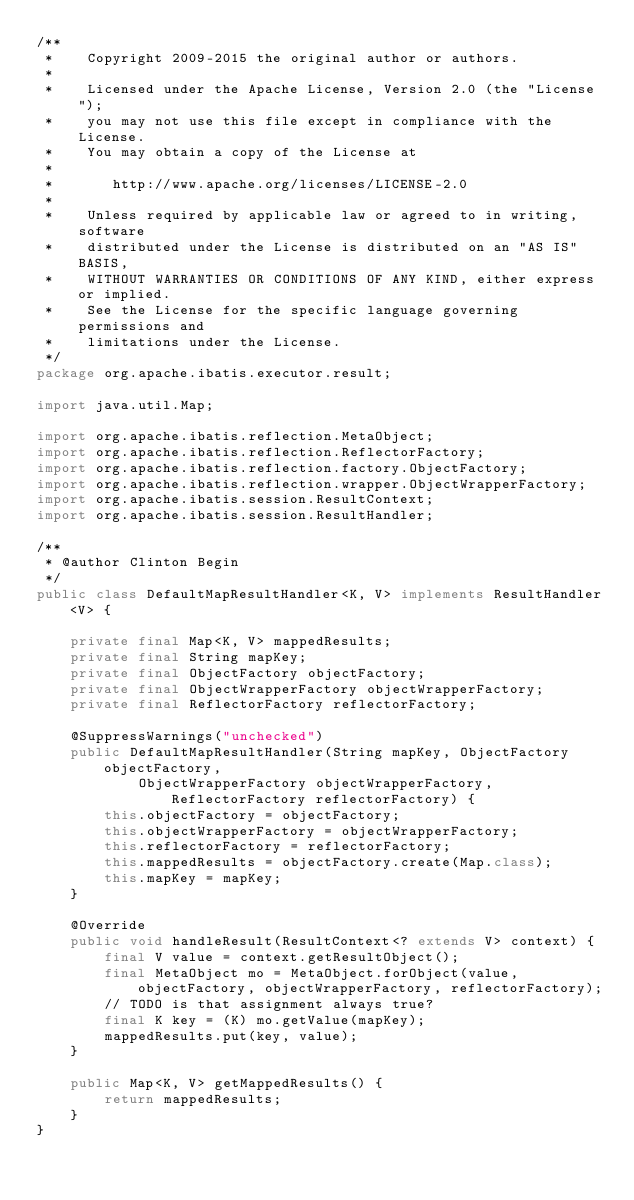Convert code to text. <code><loc_0><loc_0><loc_500><loc_500><_Java_>/**
 *    Copyright 2009-2015 the original author or authors.
 *
 *    Licensed under the Apache License, Version 2.0 (the "License");
 *    you may not use this file except in compliance with the License.
 *    You may obtain a copy of the License at
 *
 *       http://www.apache.org/licenses/LICENSE-2.0
 *
 *    Unless required by applicable law or agreed to in writing, software
 *    distributed under the License is distributed on an "AS IS" BASIS,
 *    WITHOUT WARRANTIES OR CONDITIONS OF ANY KIND, either express or implied.
 *    See the License for the specific language governing permissions and
 *    limitations under the License.
 */
package org.apache.ibatis.executor.result;

import java.util.Map;

import org.apache.ibatis.reflection.MetaObject;
import org.apache.ibatis.reflection.ReflectorFactory;
import org.apache.ibatis.reflection.factory.ObjectFactory;
import org.apache.ibatis.reflection.wrapper.ObjectWrapperFactory;
import org.apache.ibatis.session.ResultContext;
import org.apache.ibatis.session.ResultHandler;

/**
 * @author Clinton Begin
 */
public class DefaultMapResultHandler<K, V> implements ResultHandler<V> {

	private final Map<K, V> mappedResults;
	private final String mapKey;
	private final ObjectFactory objectFactory;
	private final ObjectWrapperFactory objectWrapperFactory;
	private final ReflectorFactory reflectorFactory;

	@SuppressWarnings("unchecked")
	public DefaultMapResultHandler(String mapKey, ObjectFactory objectFactory,
			ObjectWrapperFactory objectWrapperFactory, ReflectorFactory reflectorFactory) {
		this.objectFactory = objectFactory;
		this.objectWrapperFactory = objectWrapperFactory;
		this.reflectorFactory = reflectorFactory;
		this.mappedResults = objectFactory.create(Map.class);
		this.mapKey = mapKey;
	}

	@Override
	public void handleResult(ResultContext<? extends V> context) {
		final V value = context.getResultObject();
		final MetaObject mo = MetaObject.forObject(value, objectFactory, objectWrapperFactory, reflectorFactory);
		// TODO is that assignment always true?
		final K key = (K) mo.getValue(mapKey);
		mappedResults.put(key, value);
	}

	public Map<K, V> getMappedResults() {
		return mappedResults;
	}
}
</code> 